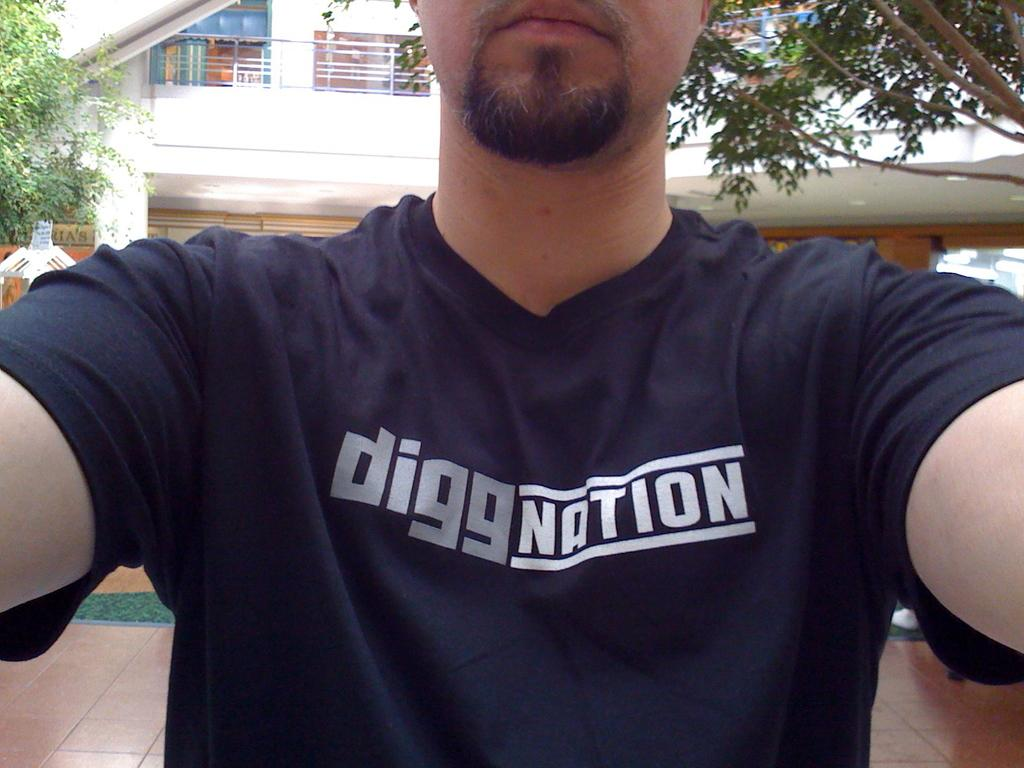Provide a one-sentence caption for the provided image. A man is wearing a blue t-shirt that says digg nation. 